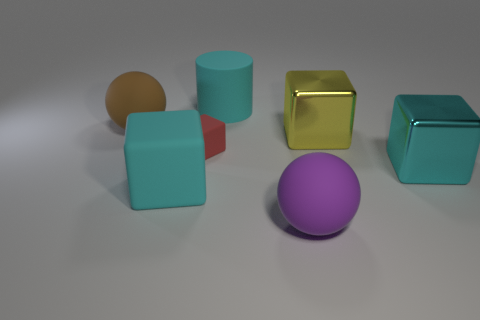Does the cyan rubber object in front of the brown sphere have the same shape as the small red matte thing?
Offer a terse response. Yes. Is the number of matte balls that are on the right side of the small red rubber block greater than the number of tiny objects?
Your answer should be very brief. No. Is the color of the big block left of the large purple sphere the same as the large rubber cylinder?
Keep it short and to the point. Yes. Is there anything else that is the same color as the tiny matte cube?
Your answer should be compact. No. What color is the matte thing in front of the cyan thing to the left of the big matte cylinder that is right of the small red rubber cube?
Provide a succinct answer. Purple. Is the size of the purple sphere the same as the cyan shiny block?
Make the answer very short. Yes. How many other cyan shiny things have the same size as the cyan metal thing?
Ensure brevity in your answer.  0. There is a rubber object that is the same color as the big matte cube; what is its shape?
Offer a very short reply. Cylinder. Is the material of the cyan block that is right of the small red matte block the same as the sphere left of the tiny matte object?
Your answer should be compact. No. Is there anything else that is the same shape as the small object?
Your answer should be compact. Yes. 